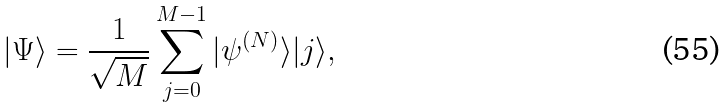<formula> <loc_0><loc_0><loc_500><loc_500>| \Psi \rangle = \frac { 1 } { \sqrt { M } } \sum _ { j = 0 } ^ { M - 1 } | \psi ^ { ( N ) } \rangle | j \rangle ,</formula> 